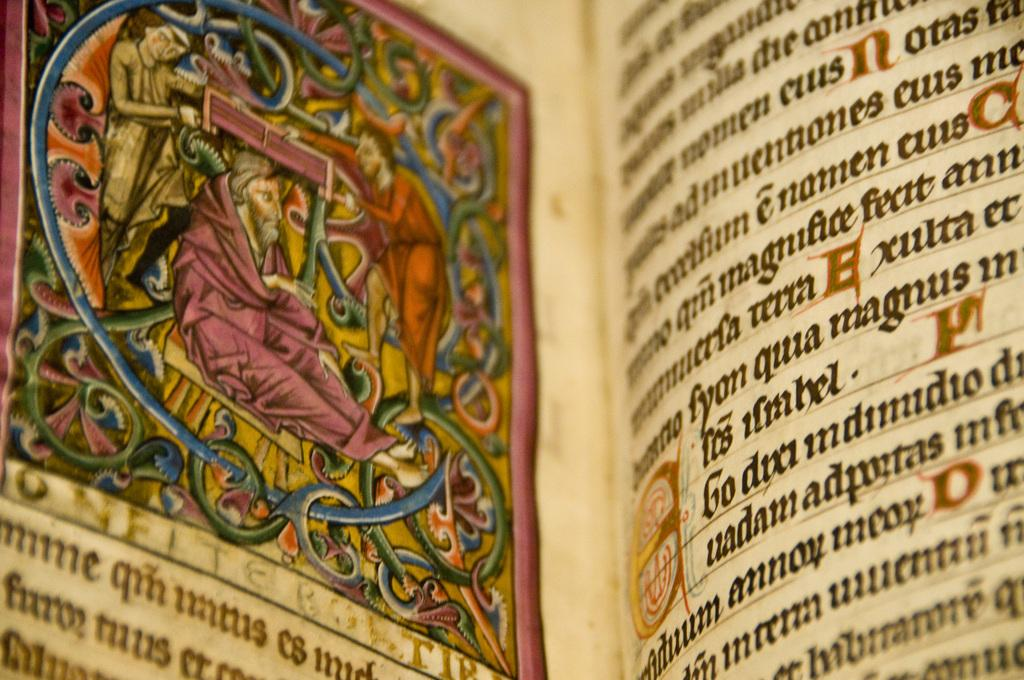<image>
Summarize the visual content of the image. Book open on a page that has the word "GO" next to a red symbol. 